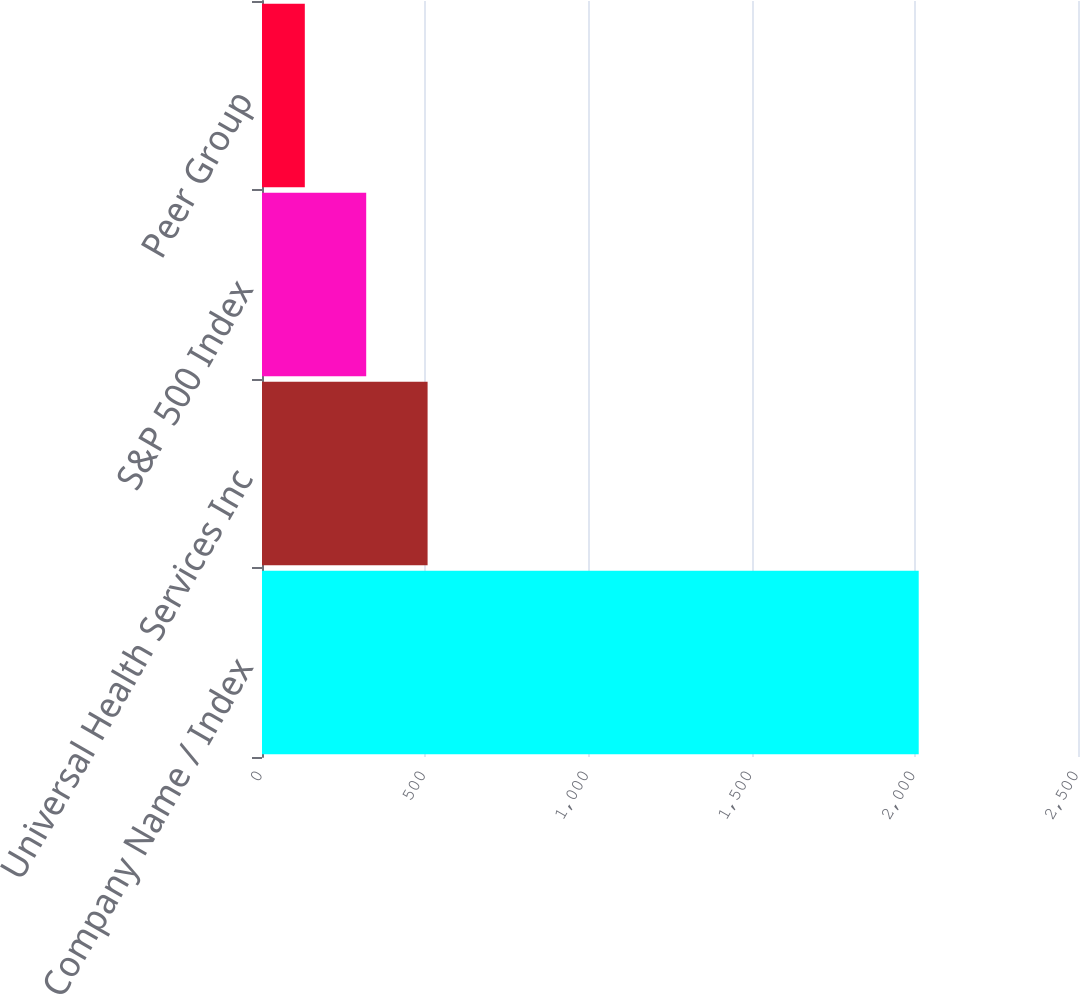Convert chart to OTSL. <chart><loc_0><loc_0><loc_500><loc_500><bar_chart><fcel>Company Name / Index<fcel>Universal Health Services Inc<fcel>S&P 500 Index<fcel>Peer Group<nl><fcel>2012<fcel>507.33<fcel>319.25<fcel>131.17<nl></chart> 